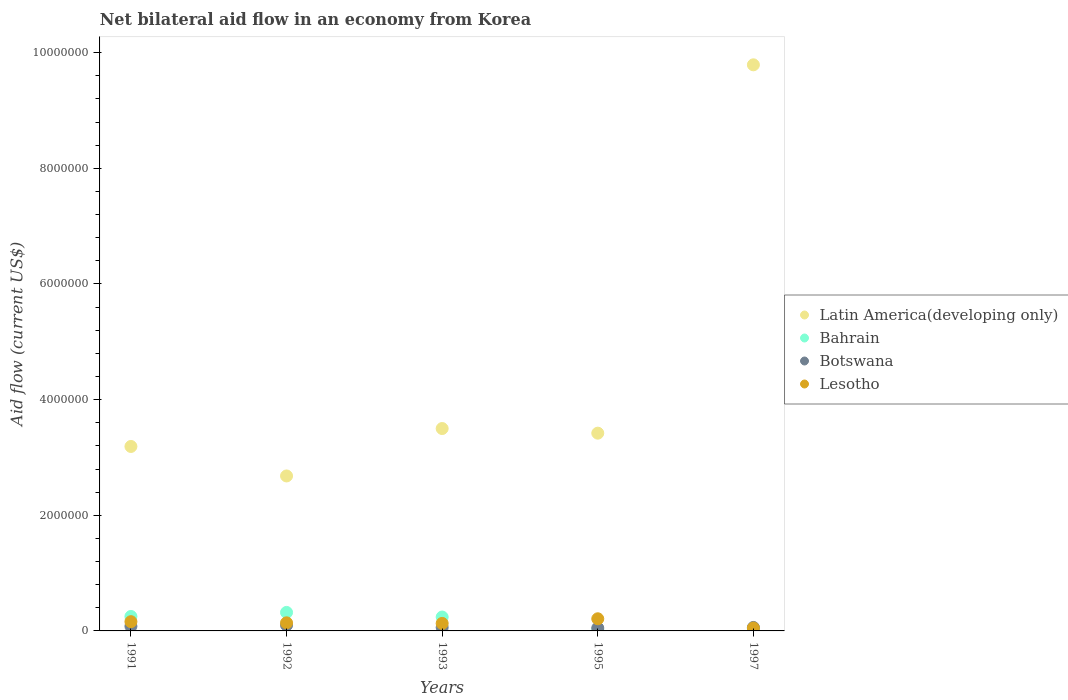Is the number of dotlines equal to the number of legend labels?
Provide a short and direct response. Yes. What is the net bilateral aid flow in Latin America(developing only) in 1995?
Offer a very short reply. 3.42e+06. Across all years, what is the minimum net bilateral aid flow in Bahrain?
Your answer should be compact. 2.00e+04. What is the total net bilateral aid flow in Botswana in the graph?
Ensure brevity in your answer.  3.50e+05. What is the difference between the net bilateral aid flow in Botswana in 1991 and the net bilateral aid flow in Bahrain in 1995?
Offer a very short reply. 6.00e+04. What is the average net bilateral aid flow in Latin America(developing only) per year?
Ensure brevity in your answer.  4.52e+06. What is the ratio of the net bilateral aid flow in Botswana in 1992 to that in 1997?
Your answer should be compact. 1.67. Is the difference between the net bilateral aid flow in Botswana in 1995 and 1997 greater than the difference between the net bilateral aid flow in Bahrain in 1995 and 1997?
Your answer should be very brief. Yes. What is the difference between the highest and the second highest net bilateral aid flow in Latin America(developing only)?
Provide a short and direct response. 6.29e+06. What is the difference between the highest and the lowest net bilateral aid flow in Lesotho?
Provide a succinct answer. 1.60e+05. Is the sum of the net bilateral aid flow in Botswana in 1991 and 1992 greater than the maximum net bilateral aid flow in Bahrain across all years?
Keep it short and to the point. No. Is it the case that in every year, the sum of the net bilateral aid flow in Bahrain and net bilateral aid flow in Botswana  is greater than the net bilateral aid flow in Lesotho?
Keep it short and to the point. No. Does the net bilateral aid flow in Latin America(developing only) monotonically increase over the years?
Keep it short and to the point. No. How many dotlines are there?
Provide a short and direct response. 4. How many years are there in the graph?
Provide a short and direct response. 5. What is the difference between two consecutive major ticks on the Y-axis?
Keep it short and to the point. 2.00e+06. Are the values on the major ticks of Y-axis written in scientific E-notation?
Keep it short and to the point. No. Does the graph contain any zero values?
Provide a short and direct response. No. Does the graph contain grids?
Keep it short and to the point. No. What is the title of the graph?
Your answer should be compact. Net bilateral aid flow in an economy from Korea. Does "Estonia" appear as one of the legend labels in the graph?
Your response must be concise. No. What is the Aid flow (current US$) of Latin America(developing only) in 1991?
Make the answer very short. 3.19e+06. What is the Aid flow (current US$) in Bahrain in 1991?
Provide a short and direct response. 2.50e+05. What is the Aid flow (current US$) in Botswana in 1991?
Provide a succinct answer. 8.00e+04. What is the Aid flow (current US$) in Latin America(developing only) in 1992?
Your answer should be very brief. 2.68e+06. What is the Aid flow (current US$) in Botswana in 1992?
Give a very brief answer. 1.00e+05. What is the Aid flow (current US$) of Latin America(developing only) in 1993?
Your answer should be very brief. 3.50e+06. What is the Aid flow (current US$) in Bahrain in 1993?
Your response must be concise. 2.40e+05. What is the Aid flow (current US$) of Lesotho in 1993?
Ensure brevity in your answer.  1.30e+05. What is the Aid flow (current US$) in Latin America(developing only) in 1995?
Provide a succinct answer. 3.42e+06. What is the Aid flow (current US$) in Botswana in 1995?
Your answer should be very brief. 5.00e+04. What is the Aid flow (current US$) in Latin America(developing only) in 1997?
Your answer should be very brief. 9.79e+06. What is the Aid flow (current US$) in Botswana in 1997?
Give a very brief answer. 6.00e+04. Across all years, what is the maximum Aid flow (current US$) in Latin America(developing only)?
Provide a succinct answer. 9.79e+06. Across all years, what is the maximum Aid flow (current US$) in Bahrain?
Provide a short and direct response. 3.20e+05. Across all years, what is the maximum Aid flow (current US$) of Botswana?
Your answer should be very brief. 1.00e+05. Across all years, what is the maximum Aid flow (current US$) of Lesotho?
Keep it short and to the point. 2.10e+05. Across all years, what is the minimum Aid flow (current US$) in Latin America(developing only)?
Provide a succinct answer. 2.68e+06. Across all years, what is the minimum Aid flow (current US$) of Lesotho?
Keep it short and to the point. 5.00e+04. What is the total Aid flow (current US$) of Latin America(developing only) in the graph?
Give a very brief answer. 2.26e+07. What is the total Aid flow (current US$) in Bahrain in the graph?
Your answer should be very brief. 8.70e+05. What is the total Aid flow (current US$) of Lesotho in the graph?
Ensure brevity in your answer.  6.90e+05. What is the difference between the Aid flow (current US$) of Latin America(developing only) in 1991 and that in 1992?
Your response must be concise. 5.10e+05. What is the difference between the Aid flow (current US$) of Bahrain in 1991 and that in 1992?
Keep it short and to the point. -7.00e+04. What is the difference between the Aid flow (current US$) in Botswana in 1991 and that in 1992?
Keep it short and to the point. -2.00e+04. What is the difference between the Aid flow (current US$) of Latin America(developing only) in 1991 and that in 1993?
Ensure brevity in your answer.  -3.10e+05. What is the difference between the Aid flow (current US$) in Bahrain in 1991 and that in 1993?
Offer a very short reply. 10000. What is the difference between the Aid flow (current US$) of Latin America(developing only) in 1991 and that in 1995?
Offer a very short reply. -2.30e+05. What is the difference between the Aid flow (current US$) in Bahrain in 1991 and that in 1995?
Your answer should be compact. 2.30e+05. What is the difference between the Aid flow (current US$) of Lesotho in 1991 and that in 1995?
Your answer should be compact. -5.00e+04. What is the difference between the Aid flow (current US$) in Latin America(developing only) in 1991 and that in 1997?
Provide a succinct answer. -6.60e+06. What is the difference between the Aid flow (current US$) in Botswana in 1991 and that in 1997?
Ensure brevity in your answer.  2.00e+04. What is the difference between the Aid flow (current US$) of Lesotho in 1991 and that in 1997?
Ensure brevity in your answer.  1.10e+05. What is the difference between the Aid flow (current US$) in Latin America(developing only) in 1992 and that in 1993?
Your response must be concise. -8.20e+05. What is the difference between the Aid flow (current US$) in Bahrain in 1992 and that in 1993?
Give a very brief answer. 8.00e+04. What is the difference between the Aid flow (current US$) in Lesotho in 1992 and that in 1993?
Make the answer very short. 10000. What is the difference between the Aid flow (current US$) in Latin America(developing only) in 1992 and that in 1995?
Your response must be concise. -7.40e+05. What is the difference between the Aid flow (current US$) in Botswana in 1992 and that in 1995?
Provide a succinct answer. 5.00e+04. What is the difference between the Aid flow (current US$) of Latin America(developing only) in 1992 and that in 1997?
Give a very brief answer. -7.11e+06. What is the difference between the Aid flow (current US$) of Botswana in 1992 and that in 1997?
Your answer should be compact. 4.00e+04. What is the difference between the Aid flow (current US$) of Lesotho in 1992 and that in 1997?
Ensure brevity in your answer.  9.00e+04. What is the difference between the Aid flow (current US$) of Botswana in 1993 and that in 1995?
Make the answer very short. 10000. What is the difference between the Aid flow (current US$) of Latin America(developing only) in 1993 and that in 1997?
Offer a very short reply. -6.29e+06. What is the difference between the Aid flow (current US$) in Lesotho in 1993 and that in 1997?
Your answer should be compact. 8.00e+04. What is the difference between the Aid flow (current US$) in Latin America(developing only) in 1995 and that in 1997?
Give a very brief answer. -6.37e+06. What is the difference between the Aid flow (current US$) of Latin America(developing only) in 1991 and the Aid flow (current US$) of Bahrain in 1992?
Ensure brevity in your answer.  2.87e+06. What is the difference between the Aid flow (current US$) in Latin America(developing only) in 1991 and the Aid flow (current US$) in Botswana in 1992?
Your answer should be very brief. 3.09e+06. What is the difference between the Aid flow (current US$) in Latin America(developing only) in 1991 and the Aid flow (current US$) in Lesotho in 1992?
Keep it short and to the point. 3.05e+06. What is the difference between the Aid flow (current US$) in Botswana in 1991 and the Aid flow (current US$) in Lesotho in 1992?
Your response must be concise. -6.00e+04. What is the difference between the Aid flow (current US$) of Latin America(developing only) in 1991 and the Aid flow (current US$) of Bahrain in 1993?
Keep it short and to the point. 2.95e+06. What is the difference between the Aid flow (current US$) in Latin America(developing only) in 1991 and the Aid flow (current US$) in Botswana in 1993?
Provide a succinct answer. 3.13e+06. What is the difference between the Aid flow (current US$) in Latin America(developing only) in 1991 and the Aid flow (current US$) in Lesotho in 1993?
Make the answer very short. 3.06e+06. What is the difference between the Aid flow (current US$) of Bahrain in 1991 and the Aid flow (current US$) of Botswana in 1993?
Give a very brief answer. 1.90e+05. What is the difference between the Aid flow (current US$) in Botswana in 1991 and the Aid flow (current US$) in Lesotho in 1993?
Your answer should be compact. -5.00e+04. What is the difference between the Aid flow (current US$) in Latin America(developing only) in 1991 and the Aid flow (current US$) in Bahrain in 1995?
Keep it short and to the point. 3.17e+06. What is the difference between the Aid flow (current US$) of Latin America(developing only) in 1991 and the Aid flow (current US$) of Botswana in 1995?
Offer a terse response. 3.14e+06. What is the difference between the Aid flow (current US$) of Latin America(developing only) in 1991 and the Aid flow (current US$) of Lesotho in 1995?
Give a very brief answer. 2.98e+06. What is the difference between the Aid flow (current US$) of Bahrain in 1991 and the Aid flow (current US$) of Lesotho in 1995?
Your answer should be very brief. 4.00e+04. What is the difference between the Aid flow (current US$) in Latin America(developing only) in 1991 and the Aid flow (current US$) in Bahrain in 1997?
Offer a very short reply. 3.15e+06. What is the difference between the Aid flow (current US$) of Latin America(developing only) in 1991 and the Aid flow (current US$) of Botswana in 1997?
Offer a terse response. 3.13e+06. What is the difference between the Aid flow (current US$) in Latin America(developing only) in 1991 and the Aid flow (current US$) in Lesotho in 1997?
Make the answer very short. 3.14e+06. What is the difference between the Aid flow (current US$) of Bahrain in 1991 and the Aid flow (current US$) of Botswana in 1997?
Provide a short and direct response. 1.90e+05. What is the difference between the Aid flow (current US$) in Bahrain in 1991 and the Aid flow (current US$) in Lesotho in 1997?
Your response must be concise. 2.00e+05. What is the difference between the Aid flow (current US$) of Latin America(developing only) in 1992 and the Aid flow (current US$) of Bahrain in 1993?
Offer a very short reply. 2.44e+06. What is the difference between the Aid flow (current US$) of Latin America(developing only) in 1992 and the Aid flow (current US$) of Botswana in 1993?
Provide a succinct answer. 2.62e+06. What is the difference between the Aid flow (current US$) in Latin America(developing only) in 1992 and the Aid flow (current US$) in Lesotho in 1993?
Your answer should be compact. 2.55e+06. What is the difference between the Aid flow (current US$) of Bahrain in 1992 and the Aid flow (current US$) of Botswana in 1993?
Offer a terse response. 2.60e+05. What is the difference between the Aid flow (current US$) in Bahrain in 1992 and the Aid flow (current US$) in Lesotho in 1993?
Make the answer very short. 1.90e+05. What is the difference between the Aid flow (current US$) in Botswana in 1992 and the Aid flow (current US$) in Lesotho in 1993?
Ensure brevity in your answer.  -3.00e+04. What is the difference between the Aid flow (current US$) of Latin America(developing only) in 1992 and the Aid flow (current US$) of Bahrain in 1995?
Offer a terse response. 2.66e+06. What is the difference between the Aid flow (current US$) of Latin America(developing only) in 1992 and the Aid flow (current US$) of Botswana in 1995?
Offer a very short reply. 2.63e+06. What is the difference between the Aid flow (current US$) of Latin America(developing only) in 1992 and the Aid flow (current US$) of Lesotho in 1995?
Ensure brevity in your answer.  2.47e+06. What is the difference between the Aid flow (current US$) in Bahrain in 1992 and the Aid flow (current US$) in Botswana in 1995?
Make the answer very short. 2.70e+05. What is the difference between the Aid flow (current US$) in Bahrain in 1992 and the Aid flow (current US$) in Lesotho in 1995?
Make the answer very short. 1.10e+05. What is the difference between the Aid flow (current US$) of Botswana in 1992 and the Aid flow (current US$) of Lesotho in 1995?
Make the answer very short. -1.10e+05. What is the difference between the Aid flow (current US$) of Latin America(developing only) in 1992 and the Aid flow (current US$) of Bahrain in 1997?
Offer a very short reply. 2.64e+06. What is the difference between the Aid flow (current US$) of Latin America(developing only) in 1992 and the Aid flow (current US$) of Botswana in 1997?
Your answer should be very brief. 2.62e+06. What is the difference between the Aid flow (current US$) in Latin America(developing only) in 1992 and the Aid flow (current US$) in Lesotho in 1997?
Offer a very short reply. 2.63e+06. What is the difference between the Aid flow (current US$) of Latin America(developing only) in 1993 and the Aid flow (current US$) of Bahrain in 1995?
Provide a short and direct response. 3.48e+06. What is the difference between the Aid flow (current US$) of Latin America(developing only) in 1993 and the Aid flow (current US$) of Botswana in 1995?
Keep it short and to the point. 3.45e+06. What is the difference between the Aid flow (current US$) of Latin America(developing only) in 1993 and the Aid flow (current US$) of Lesotho in 1995?
Offer a terse response. 3.29e+06. What is the difference between the Aid flow (current US$) in Bahrain in 1993 and the Aid flow (current US$) in Botswana in 1995?
Provide a succinct answer. 1.90e+05. What is the difference between the Aid flow (current US$) in Bahrain in 1993 and the Aid flow (current US$) in Lesotho in 1995?
Your answer should be compact. 3.00e+04. What is the difference between the Aid flow (current US$) of Latin America(developing only) in 1993 and the Aid flow (current US$) of Bahrain in 1997?
Your response must be concise. 3.46e+06. What is the difference between the Aid flow (current US$) of Latin America(developing only) in 1993 and the Aid flow (current US$) of Botswana in 1997?
Offer a terse response. 3.44e+06. What is the difference between the Aid flow (current US$) in Latin America(developing only) in 1993 and the Aid flow (current US$) in Lesotho in 1997?
Provide a succinct answer. 3.45e+06. What is the difference between the Aid flow (current US$) of Bahrain in 1993 and the Aid flow (current US$) of Botswana in 1997?
Provide a short and direct response. 1.80e+05. What is the difference between the Aid flow (current US$) of Bahrain in 1993 and the Aid flow (current US$) of Lesotho in 1997?
Offer a very short reply. 1.90e+05. What is the difference between the Aid flow (current US$) of Latin America(developing only) in 1995 and the Aid flow (current US$) of Bahrain in 1997?
Your answer should be compact. 3.38e+06. What is the difference between the Aid flow (current US$) of Latin America(developing only) in 1995 and the Aid flow (current US$) of Botswana in 1997?
Offer a terse response. 3.36e+06. What is the difference between the Aid flow (current US$) of Latin America(developing only) in 1995 and the Aid flow (current US$) of Lesotho in 1997?
Offer a very short reply. 3.37e+06. What is the difference between the Aid flow (current US$) of Bahrain in 1995 and the Aid flow (current US$) of Botswana in 1997?
Ensure brevity in your answer.  -4.00e+04. What is the average Aid flow (current US$) of Latin America(developing only) per year?
Keep it short and to the point. 4.52e+06. What is the average Aid flow (current US$) in Bahrain per year?
Keep it short and to the point. 1.74e+05. What is the average Aid flow (current US$) in Botswana per year?
Ensure brevity in your answer.  7.00e+04. What is the average Aid flow (current US$) of Lesotho per year?
Offer a terse response. 1.38e+05. In the year 1991, what is the difference between the Aid flow (current US$) in Latin America(developing only) and Aid flow (current US$) in Bahrain?
Ensure brevity in your answer.  2.94e+06. In the year 1991, what is the difference between the Aid flow (current US$) in Latin America(developing only) and Aid flow (current US$) in Botswana?
Provide a succinct answer. 3.11e+06. In the year 1991, what is the difference between the Aid flow (current US$) in Latin America(developing only) and Aid flow (current US$) in Lesotho?
Ensure brevity in your answer.  3.03e+06. In the year 1991, what is the difference between the Aid flow (current US$) of Bahrain and Aid flow (current US$) of Botswana?
Keep it short and to the point. 1.70e+05. In the year 1991, what is the difference between the Aid flow (current US$) of Bahrain and Aid flow (current US$) of Lesotho?
Keep it short and to the point. 9.00e+04. In the year 1992, what is the difference between the Aid flow (current US$) in Latin America(developing only) and Aid flow (current US$) in Bahrain?
Keep it short and to the point. 2.36e+06. In the year 1992, what is the difference between the Aid flow (current US$) of Latin America(developing only) and Aid flow (current US$) of Botswana?
Provide a succinct answer. 2.58e+06. In the year 1992, what is the difference between the Aid flow (current US$) in Latin America(developing only) and Aid flow (current US$) in Lesotho?
Keep it short and to the point. 2.54e+06. In the year 1992, what is the difference between the Aid flow (current US$) of Botswana and Aid flow (current US$) of Lesotho?
Provide a short and direct response. -4.00e+04. In the year 1993, what is the difference between the Aid flow (current US$) in Latin America(developing only) and Aid flow (current US$) in Bahrain?
Ensure brevity in your answer.  3.26e+06. In the year 1993, what is the difference between the Aid flow (current US$) of Latin America(developing only) and Aid flow (current US$) of Botswana?
Ensure brevity in your answer.  3.44e+06. In the year 1993, what is the difference between the Aid flow (current US$) in Latin America(developing only) and Aid flow (current US$) in Lesotho?
Offer a very short reply. 3.37e+06. In the year 1993, what is the difference between the Aid flow (current US$) in Bahrain and Aid flow (current US$) in Botswana?
Offer a terse response. 1.80e+05. In the year 1993, what is the difference between the Aid flow (current US$) of Bahrain and Aid flow (current US$) of Lesotho?
Make the answer very short. 1.10e+05. In the year 1993, what is the difference between the Aid flow (current US$) of Botswana and Aid flow (current US$) of Lesotho?
Your answer should be compact. -7.00e+04. In the year 1995, what is the difference between the Aid flow (current US$) of Latin America(developing only) and Aid flow (current US$) of Bahrain?
Offer a very short reply. 3.40e+06. In the year 1995, what is the difference between the Aid flow (current US$) in Latin America(developing only) and Aid flow (current US$) in Botswana?
Your answer should be very brief. 3.37e+06. In the year 1995, what is the difference between the Aid flow (current US$) in Latin America(developing only) and Aid flow (current US$) in Lesotho?
Offer a very short reply. 3.21e+06. In the year 1995, what is the difference between the Aid flow (current US$) of Bahrain and Aid flow (current US$) of Lesotho?
Offer a very short reply. -1.90e+05. In the year 1995, what is the difference between the Aid flow (current US$) of Botswana and Aid flow (current US$) of Lesotho?
Keep it short and to the point. -1.60e+05. In the year 1997, what is the difference between the Aid flow (current US$) in Latin America(developing only) and Aid flow (current US$) in Bahrain?
Keep it short and to the point. 9.75e+06. In the year 1997, what is the difference between the Aid flow (current US$) in Latin America(developing only) and Aid flow (current US$) in Botswana?
Your answer should be very brief. 9.73e+06. In the year 1997, what is the difference between the Aid flow (current US$) of Latin America(developing only) and Aid flow (current US$) of Lesotho?
Ensure brevity in your answer.  9.74e+06. In the year 1997, what is the difference between the Aid flow (current US$) in Bahrain and Aid flow (current US$) in Botswana?
Your answer should be compact. -2.00e+04. In the year 1997, what is the difference between the Aid flow (current US$) in Bahrain and Aid flow (current US$) in Lesotho?
Your answer should be very brief. -10000. In the year 1997, what is the difference between the Aid flow (current US$) of Botswana and Aid flow (current US$) of Lesotho?
Your answer should be compact. 10000. What is the ratio of the Aid flow (current US$) of Latin America(developing only) in 1991 to that in 1992?
Provide a succinct answer. 1.19. What is the ratio of the Aid flow (current US$) in Bahrain in 1991 to that in 1992?
Your answer should be compact. 0.78. What is the ratio of the Aid flow (current US$) of Latin America(developing only) in 1991 to that in 1993?
Offer a terse response. 0.91. What is the ratio of the Aid flow (current US$) of Bahrain in 1991 to that in 1993?
Keep it short and to the point. 1.04. What is the ratio of the Aid flow (current US$) of Botswana in 1991 to that in 1993?
Your answer should be compact. 1.33. What is the ratio of the Aid flow (current US$) of Lesotho in 1991 to that in 1993?
Provide a short and direct response. 1.23. What is the ratio of the Aid flow (current US$) in Latin America(developing only) in 1991 to that in 1995?
Give a very brief answer. 0.93. What is the ratio of the Aid flow (current US$) in Botswana in 1991 to that in 1995?
Provide a succinct answer. 1.6. What is the ratio of the Aid flow (current US$) of Lesotho in 1991 to that in 1995?
Your answer should be compact. 0.76. What is the ratio of the Aid flow (current US$) in Latin America(developing only) in 1991 to that in 1997?
Your answer should be very brief. 0.33. What is the ratio of the Aid flow (current US$) of Bahrain in 1991 to that in 1997?
Your response must be concise. 6.25. What is the ratio of the Aid flow (current US$) of Botswana in 1991 to that in 1997?
Give a very brief answer. 1.33. What is the ratio of the Aid flow (current US$) in Lesotho in 1991 to that in 1997?
Ensure brevity in your answer.  3.2. What is the ratio of the Aid flow (current US$) in Latin America(developing only) in 1992 to that in 1993?
Offer a terse response. 0.77. What is the ratio of the Aid flow (current US$) of Botswana in 1992 to that in 1993?
Your answer should be compact. 1.67. What is the ratio of the Aid flow (current US$) in Latin America(developing only) in 1992 to that in 1995?
Provide a succinct answer. 0.78. What is the ratio of the Aid flow (current US$) in Botswana in 1992 to that in 1995?
Ensure brevity in your answer.  2. What is the ratio of the Aid flow (current US$) of Lesotho in 1992 to that in 1995?
Provide a succinct answer. 0.67. What is the ratio of the Aid flow (current US$) in Latin America(developing only) in 1992 to that in 1997?
Offer a terse response. 0.27. What is the ratio of the Aid flow (current US$) of Bahrain in 1992 to that in 1997?
Your answer should be very brief. 8. What is the ratio of the Aid flow (current US$) of Latin America(developing only) in 1993 to that in 1995?
Keep it short and to the point. 1.02. What is the ratio of the Aid flow (current US$) of Bahrain in 1993 to that in 1995?
Provide a short and direct response. 12. What is the ratio of the Aid flow (current US$) of Lesotho in 1993 to that in 1995?
Offer a very short reply. 0.62. What is the ratio of the Aid flow (current US$) in Latin America(developing only) in 1993 to that in 1997?
Ensure brevity in your answer.  0.36. What is the ratio of the Aid flow (current US$) of Bahrain in 1993 to that in 1997?
Your answer should be very brief. 6. What is the ratio of the Aid flow (current US$) in Botswana in 1993 to that in 1997?
Your answer should be very brief. 1. What is the ratio of the Aid flow (current US$) of Lesotho in 1993 to that in 1997?
Offer a very short reply. 2.6. What is the ratio of the Aid flow (current US$) in Latin America(developing only) in 1995 to that in 1997?
Provide a short and direct response. 0.35. What is the ratio of the Aid flow (current US$) of Bahrain in 1995 to that in 1997?
Your response must be concise. 0.5. What is the difference between the highest and the second highest Aid flow (current US$) in Latin America(developing only)?
Provide a short and direct response. 6.29e+06. What is the difference between the highest and the second highest Aid flow (current US$) in Bahrain?
Your answer should be very brief. 7.00e+04. What is the difference between the highest and the second highest Aid flow (current US$) of Botswana?
Offer a very short reply. 2.00e+04. What is the difference between the highest and the second highest Aid flow (current US$) of Lesotho?
Give a very brief answer. 5.00e+04. What is the difference between the highest and the lowest Aid flow (current US$) in Latin America(developing only)?
Your answer should be very brief. 7.11e+06. What is the difference between the highest and the lowest Aid flow (current US$) in Bahrain?
Provide a short and direct response. 3.00e+05. What is the difference between the highest and the lowest Aid flow (current US$) of Botswana?
Provide a succinct answer. 5.00e+04. What is the difference between the highest and the lowest Aid flow (current US$) in Lesotho?
Your response must be concise. 1.60e+05. 